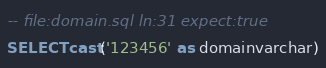<code> <loc_0><loc_0><loc_500><loc_500><_SQL_>-- file:domain.sql ln:31 expect:true
SELECT cast('123456' as domainvarchar)
</code> 